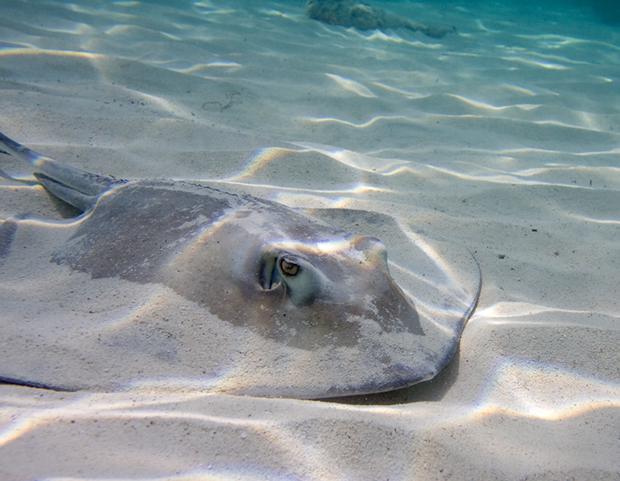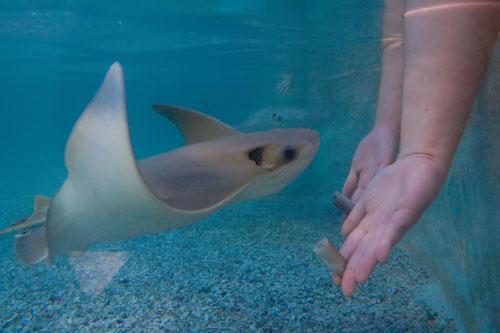The first image is the image on the left, the second image is the image on the right. Evaluate the accuracy of this statement regarding the images: "An image shows one rightward-facing stingray that is partly covered in sand.". Is it true? Answer yes or no. Yes. The first image is the image on the left, the second image is the image on the right. Examine the images to the left and right. Is the description "A single ray is sitting on the sandy bottom in the image on the left." accurate? Answer yes or no. Yes. 